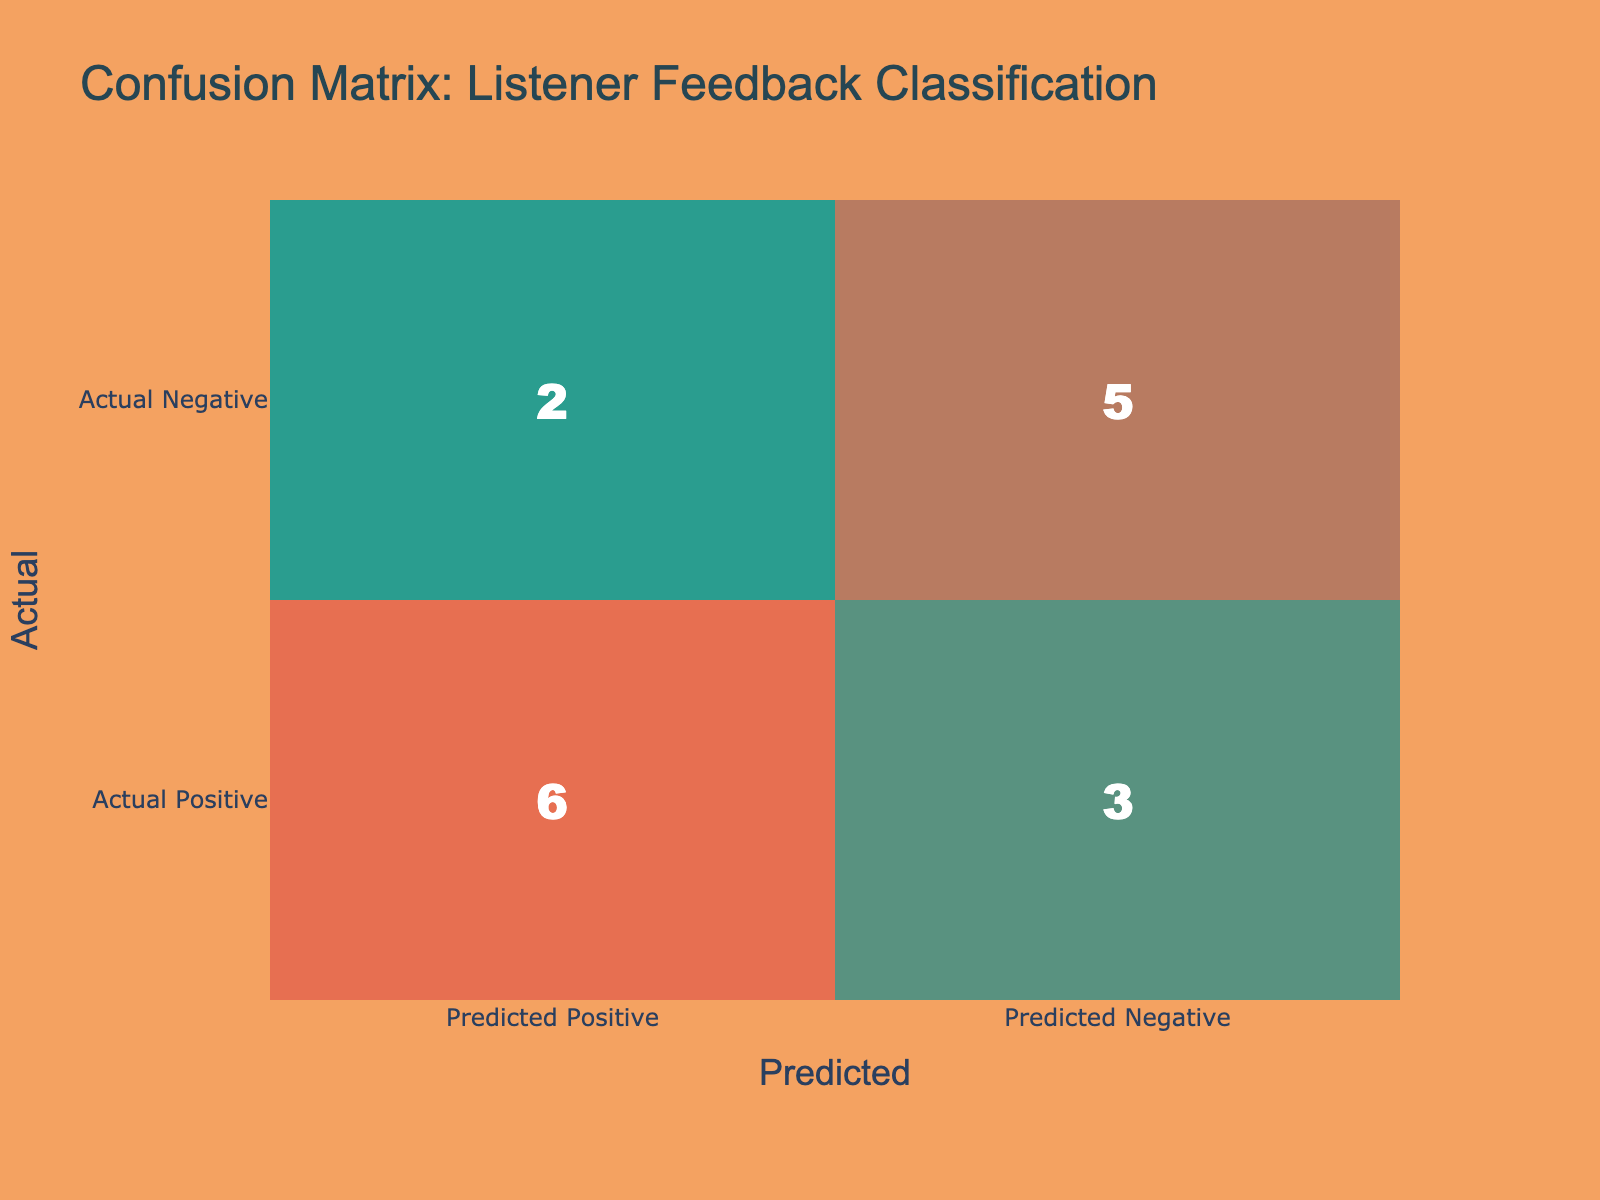What is the number of true positive reviews? Looking at the table, true positive reviews occur when the actual label is Positive and the predicted label is also Positive. From the confusion matrix, there are 6 counts in the cell for Actual Positive and Predicted Positive.
Answer: 6 How many total reviews were positively classified? To find this, we add the true positives and false positives from the matrix. The true positives (Actual Positive and Predicted Positive) are 6, and false positives (Actual Negative and Predicted Positive) are 2, so the total is 6 + 2 = 8.
Answer: 8 What is the number of true negative reviews? True negatives occur when both the actual and predicted labels are Negative. Referring to the confusion matrix, the count in the cell for Actual Negative and Predicted Negative is 4.
Answer: 4 Is the classification model better at predicting positive reviews than negative reviews? To evaluate this, we compare the sums of true positives (6) and false negatives (3) with true negatives (4) and false positives (2). Since true positives are more than true negatives, the model seems better at predicting positive reviews.
Answer: Yes What is the difference in the number of false negatives and false positives? False negatives occur when the actual label is Positive and the predicted label is Negative, which is 3 in the matrix. False positives occur when the actual label is Negative and the predicted label is Positive, which is 2. Thus, the difference is 3 - 2 = 1.
Answer: 1 What is the total number of negative reviews predicted? To determine this, we sum the values under the Predicted Negative column. The values are 3 (true negative count) and 5 (false negative count), resulting in a total of 3 + 5 = 8 predicted negative reviews.
Answer: 8 What percentage of reviews were incorrectly classified? Incorrect classifications comprise both false positives and false negatives. The sum of false positives (2) and false negatives (3) is 5. The total number of reviews is 15 (by counting all cells in the matrix). Hence, the percentage is (5/15) * 100, which equals approximately 33.33%.
Answer: 33.33% What is the total number of reviews classified? The total number of reviews is the sum of all cells in the confusion matrix. There are 6 (True Positive) + 3 (False Negative) + 2 (False Positive) + 4 (True Negative) = 15 total reviews.
Answer: 15 Which review type was predicted most accurately? By examining the counts, the true positive counts (6) exceed the true negative counts (4), indicating positive reviews are predicted more accurately since 6 > 4.
Answer: Positive reviews 